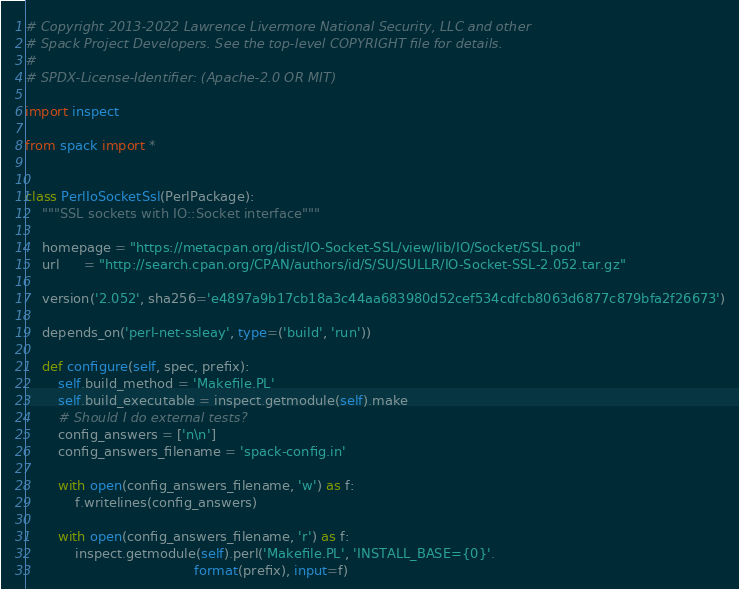<code> <loc_0><loc_0><loc_500><loc_500><_Python_># Copyright 2013-2022 Lawrence Livermore National Security, LLC and other
# Spack Project Developers. See the top-level COPYRIGHT file for details.
#
# SPDX-License-Identifier: (Apache-2.0 OR MIT)

import inspect

from spack import *


class PerlIoSocketSsl(PerlPackage):
    """SSL sockets with IO::Socket interface"""

    homepage = "https://metacpan.org/dist/IO-Socket-SSL/view/lib/IO/Socket/SSL.pod"
    url      = "http://search.cpan.org/CPAN/authors/id/S/SU/SULLR/IO-Socket-SSL-2.052.tar.gz"

    version('2.052', sha256='e4897a9b17cb18a3c44aa683980d52cef534cdfcb8063d6877c879bfa2f26673')

    depends_on('perl-net-ssleay', type=('build', 'run'))

    def configure(self, spec, prefix):
        self.build_method = 'Makefile.PL'
        self.build_executable = inspect.getmodule(self).make
        # Should I do external tests?
        config_answers = ['n\n']
        config_answers_filename = 'spack-config.in'

        with open(config_answers_filename, 'w') as f:
            f.writelines(config_answers)

        with open(config_answers_filename, 'r') as f:
            inspect.getmodule(self).perl('Makefile.PL', 'INSTALL_BASE={0}'.
                                         format(prefix), input=f)
</code> 